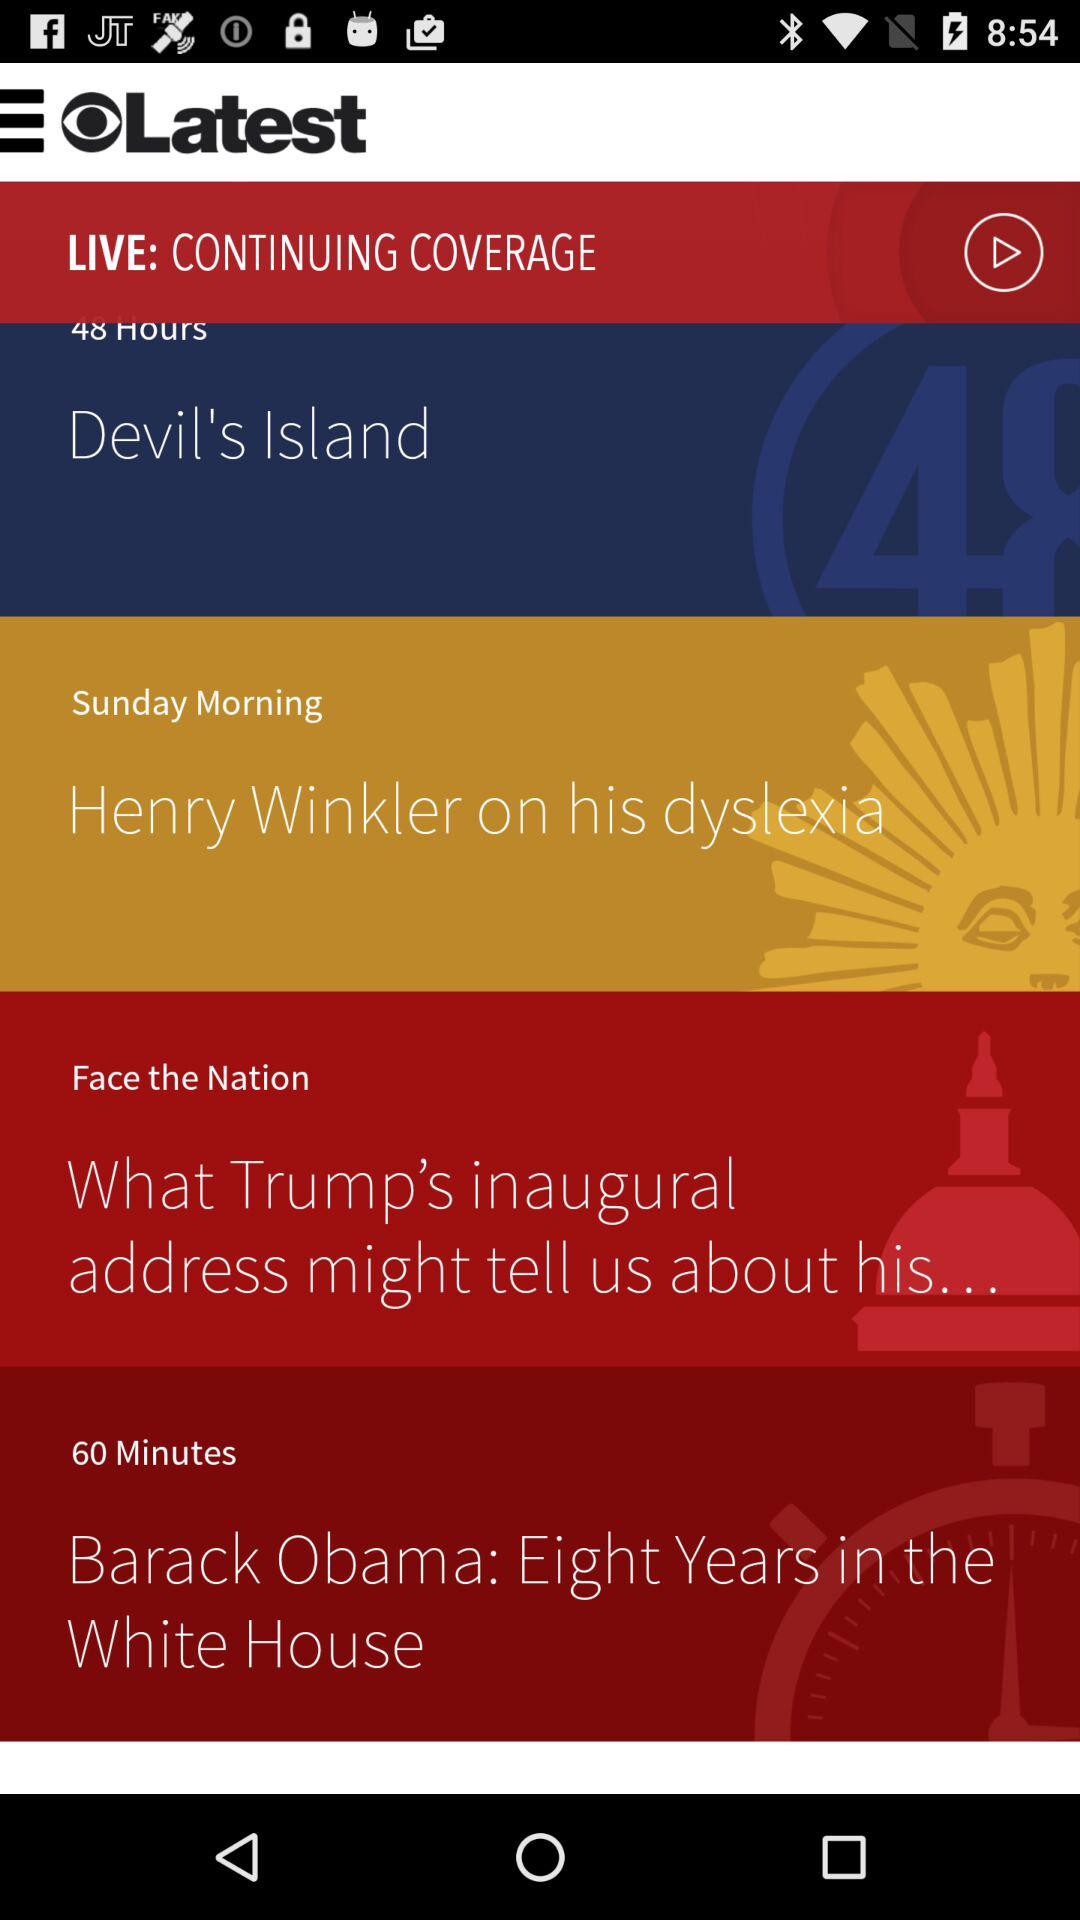What is the live coverage duration for "Barack Obama: Eight Years in the White House"? The duration is 60 minutes. 